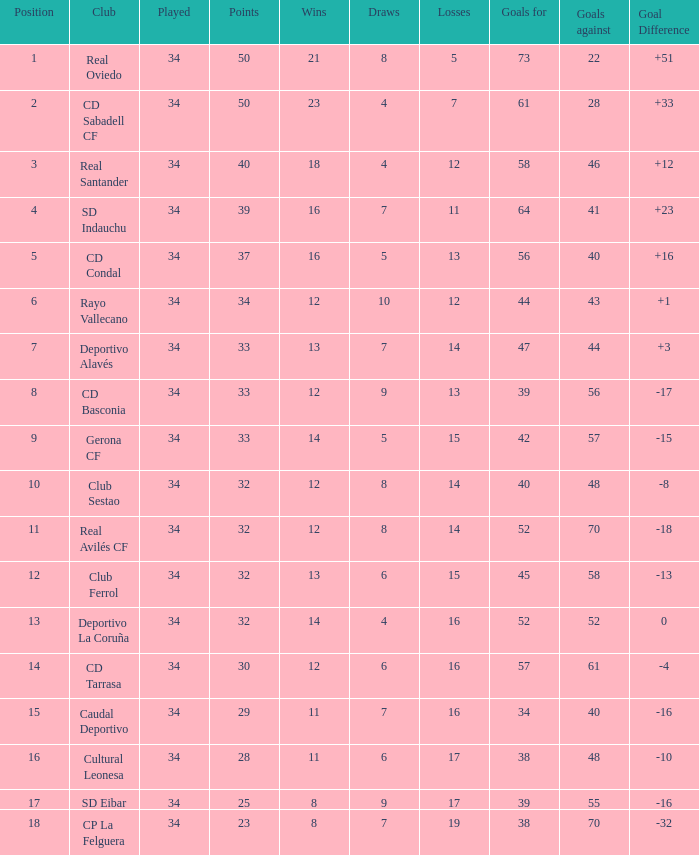How many Goals against have Played more than 34? 0.0. 